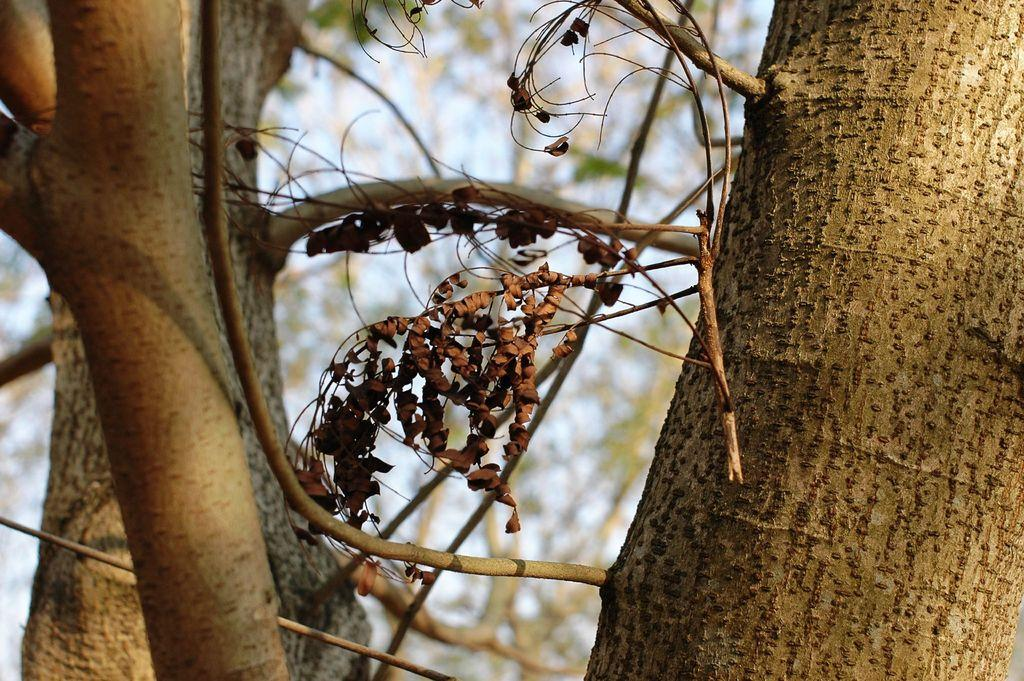What is the main subject in the foreground of the image? There are branches and a trunk of a tree in the foreground of the image. What can be seen in the middle of the image? There are dry leaves in the middle of the image. How would you describe the background of the image? The background of the image is blurred. How many toes can be seen on the loaf of bread in the image? There are no toes or loaf of bread present in the image; it features a tree with branches and dry leaves. 